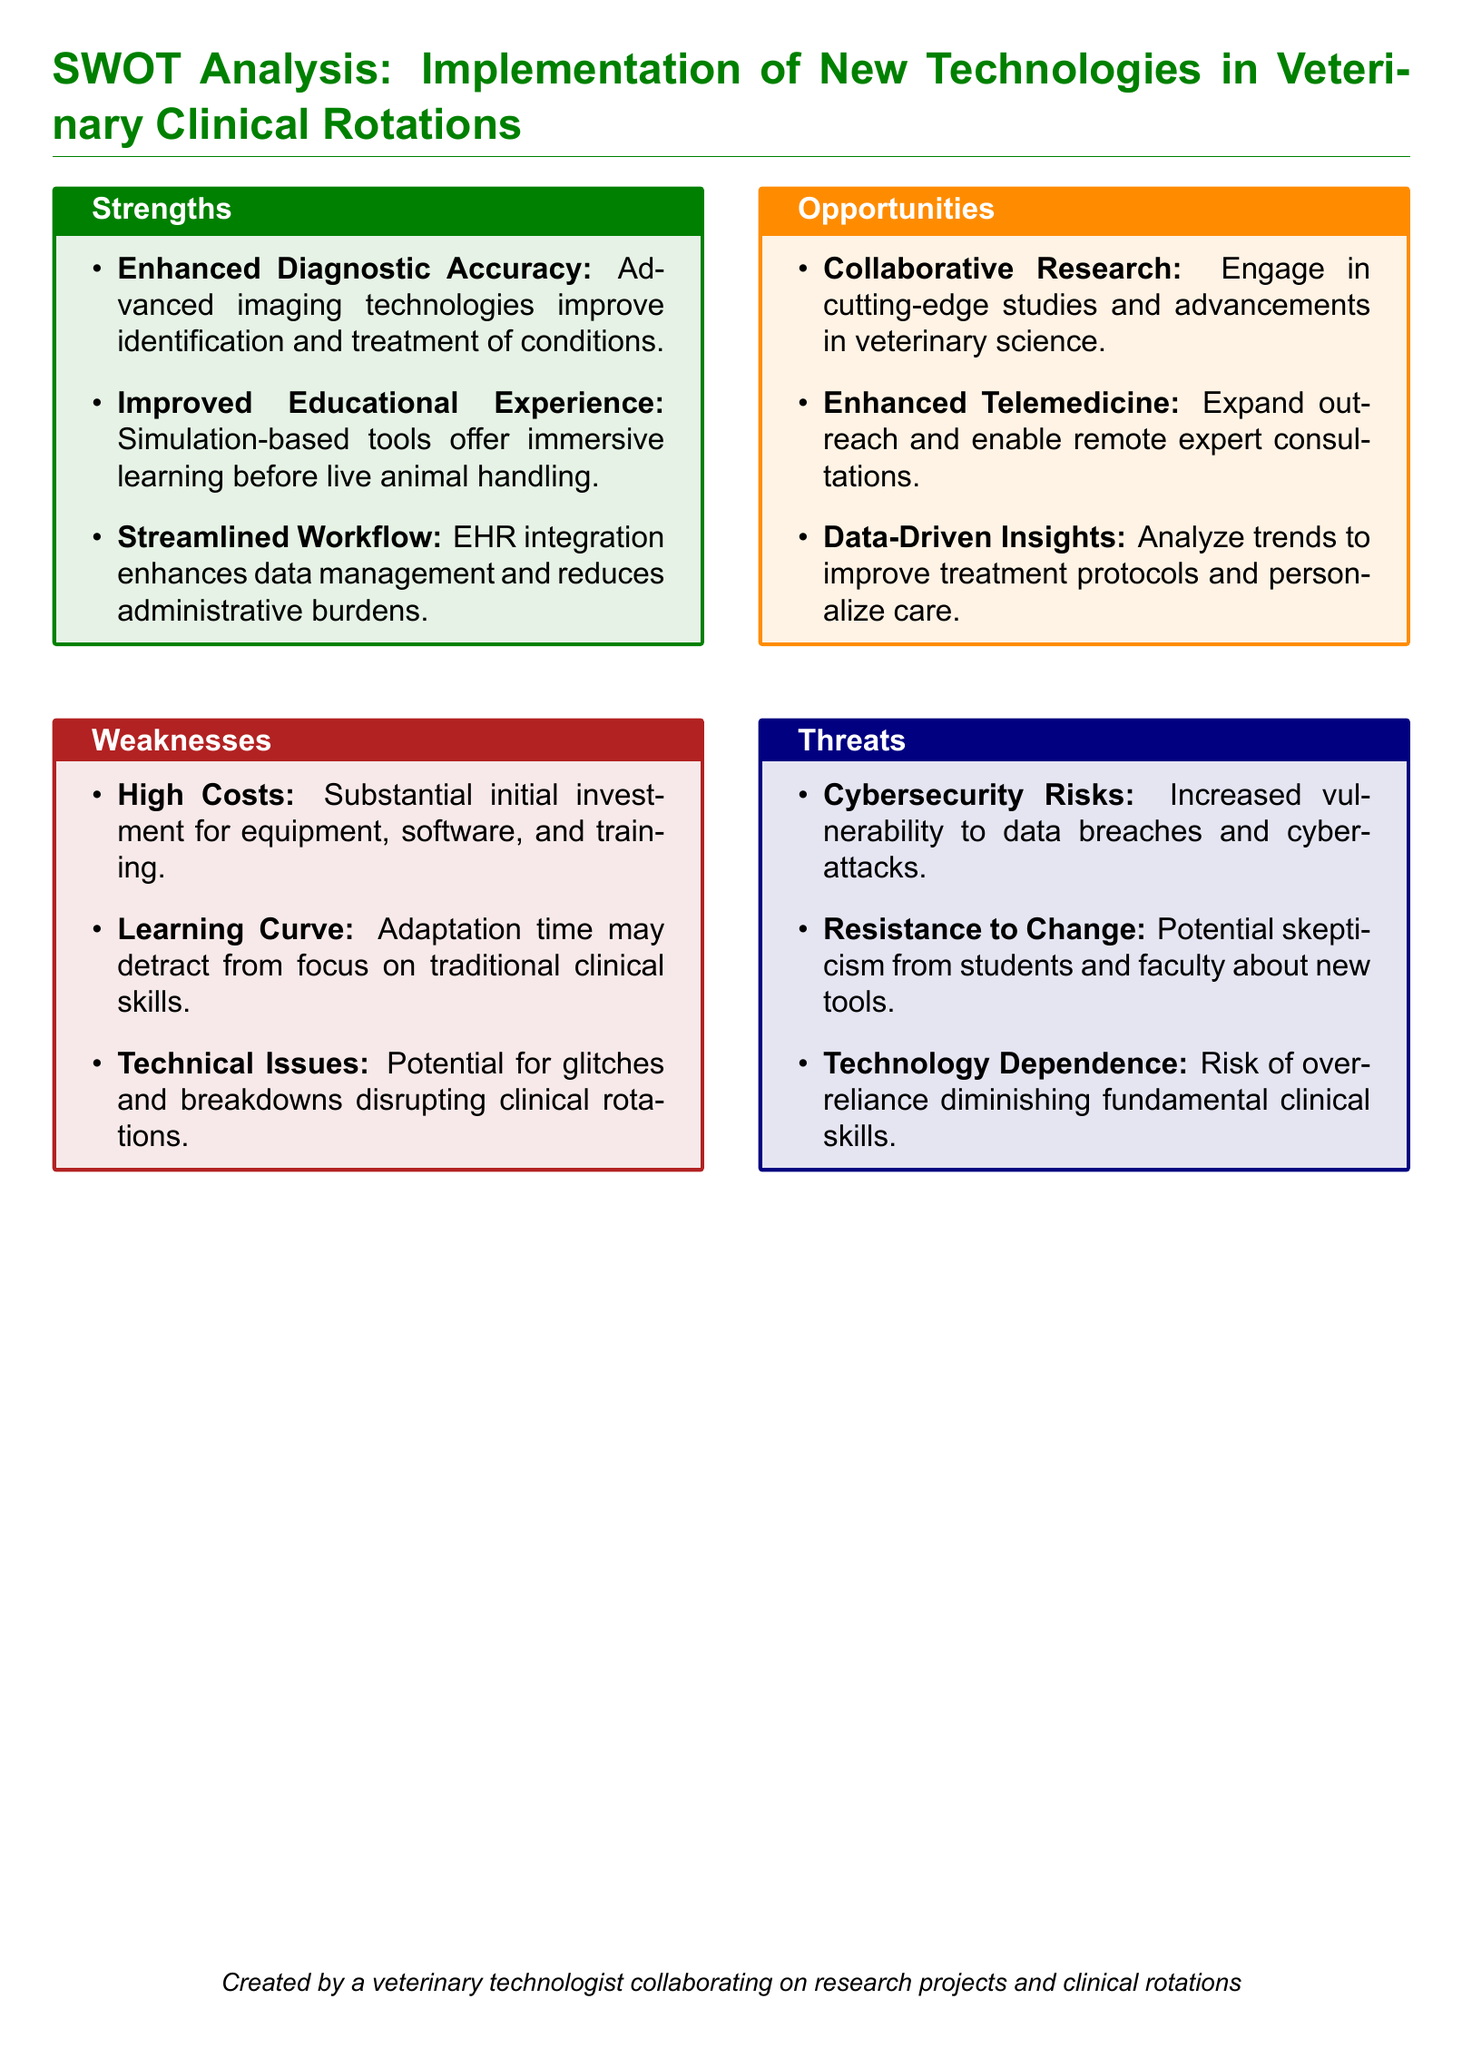What are the strengths listed in the document? The strengths are detailed in the "Strengths" section, which includes enhanced diagnostic accuracy, improved educational experience, and streamlined workflow.
Answer: Enhanced diagnostic accuracy, improved educational experience, streamlined workflow What is the first weakness identified? The first weakness is the initial investment that is necessary for implementation, which is stated in the "Weaknesses" section.
Answer: High Costs How many opportunities are presented? The document contains a list of opportunities, specifically three opportunities provided in the "Opportunities" section.
Answer: Three What is one of the threats mentioned? The threats are outlined in the "Threats" section, and one specific threat mentioned is cybersecurity risks.
Answer: Cybersecurity Risks What type of document is this? The document is structured as a SWOT analysis focusing on the implementation of new technologies in veterinary clinical rotations.
Answer: SWOT analysis How does new technology enhance the educational experience? The document states that simulation-based tools offer immersive learning experiences before students engage in live animal handling.
Answer: Simulation-based tools offer immersive learning What is a notable opportunity related to telemedicine? One opportunity listed is enhanced telemedicine, which indicates the potential for remote consultations with experts.
Answer: Enhanced Telemedicine What may result from the technology dependence mentioned? The document states that there is a risk of overreliance on technology, which can diminish fundamental clinical skills.
Answer: Diminishing fundamental clinical skills What is a potential consequence of resistance to change? Resistance to change may lead to skepticism from students and faculty regarding the new tools introduced.
Answer: Skepticism from students and faculty 